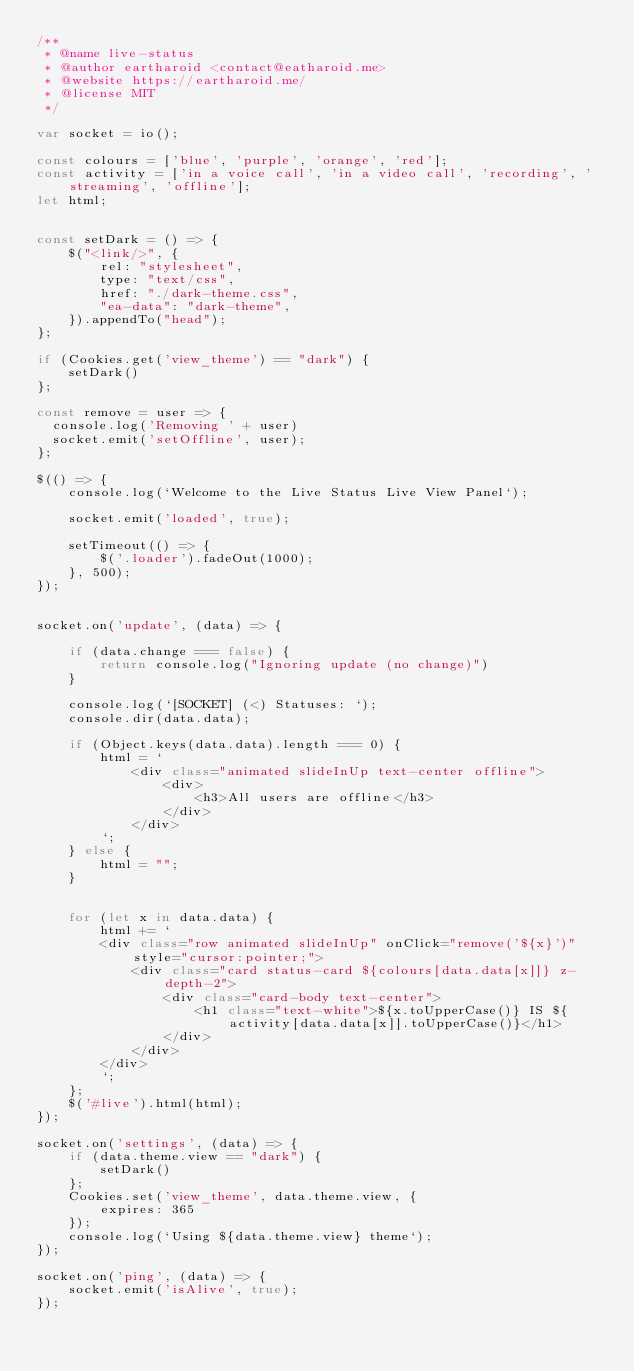<code> <loc_0><loc_0><loc_500><loc_500><_JavaScript_>/**
 * @name live-status
 * @author eartharoid <contact@eatharoid.me>
 * @website https://eartharoid.me/
 * @license MIT
 */

var socket = io();

const colours = ['blue', 'purple', 'orange', 'red'];
const activity = ['in a voice call', 'in a video call', 'recording', 'streaming', 'offline'];
let html;


const setDark = () => {
    $("<link/>", {
        rel: "stylesheet",
        type: "text/css",
        href: "./dark-theme.css",
        "ea-data": "dark-theme",
    }).appendTo("head");
};

if (Cookies.get('view_theme') == "dark") {
    setDark()
};

const remove = user => {
	console.log('Removing ' + user)
	socket.emit('setOffline', user);
};

$(() => {
    console.log(`Welcome to the Live Status Live View Panel`);

    socket.emit('loaded', true);

    setTimeout(() => {
        $('.loader').fadeOut(1000);
    }, 500);
});


socket.on('update', (data) => {

    if (data.change === false) {
        return console.log("Ignoring update (no change)")
    }

    console.log(`[SOCKET] (<) Statuses: `);
    console.dir(data.data);

    if (Object.keys(data.data).length === 0) {
        html = `
            <div class="animated slideInUp text-center offline">
                <div>
                    <h3>All users are offline</h3>
                </div>
            </div>
        `;
    } else {
        html = "";
    }


    for (let x in data.data) {
        html += `
        <div class="row animated slideInUp" onClick="remove('${x}')" style="cursor:pointer;">
            <div class="card status-card ${colours[data.data[x]]} z-depth-2">
                <div class="card-body text-center">
                    <h1 class="text-white">${x.toUpperCase()} IS ${activity[data.data[x]].toUpperCase()}</h1>
                </div>
            </div>
        </div>
        `;
    };
    $('#live').html(html);
});

socket.on('settings', (data) => {
    if (data.theme.view == "dark") {
        setDark()
    };
    Cookies.set('view_theme', data.theme.view, {
        expires: 365
    });
    console.log(`Using ${data.theme.view} theme`);
});

socket.on('ping', (data) => {
    socket.emit('isAlive', true);
});
</code> 